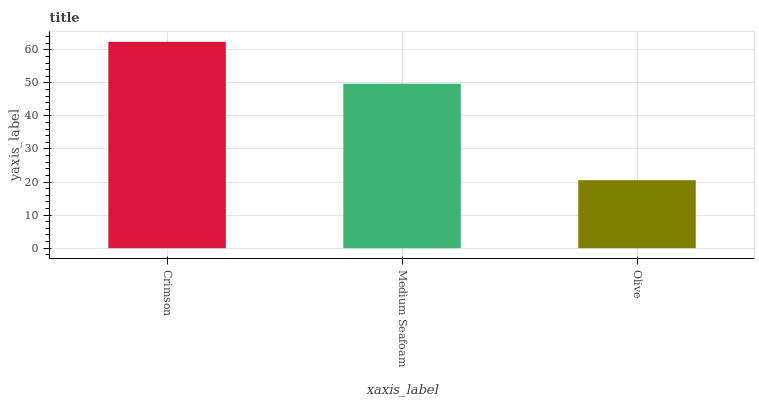Is Olive the minimum?
Answer yes or no. Yes. Is Crimson the maximum?
Answer yes or no. Yes. Is Medium Seafoam the minimum?
Answer yes or no. No. Is Medium Seafoam the maximum?
Answer yes or no. No. Is Crimson greater than Medium Seafoam?
Answer yes or no. Yes. Is Medium Seafoam less than Crimson?
Answer yes or no. Yes. Is Medium Seafoam greater than Crimson?
Answer yes or no. No. Is Crimson less than Medium Seafoam?
Answer yes or no. No. Is Medium Seafoam the high median?
Answer yes or no. Yes. Is Medium Seafoam the low median?
Answer yes or no. Yes. Is Olive the high median?
Answer yes or no. No. Is Olive the low median?
Answer yes or no. No. 